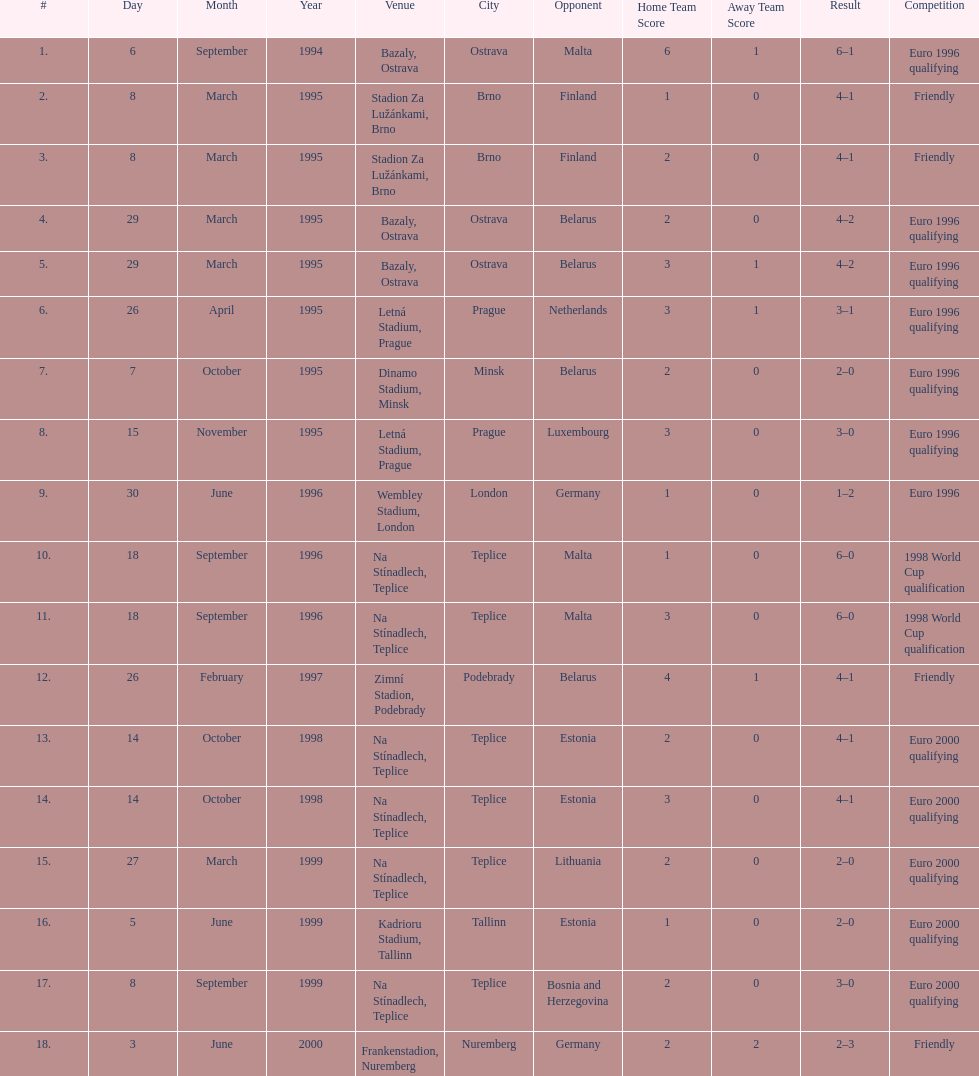How many euro 2000 qualifying competitions are listed? 4. 